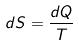<formula> <loc_0><loc_0><loc_500><loc_500>d S = \frac { d Q } { T }</formula> 